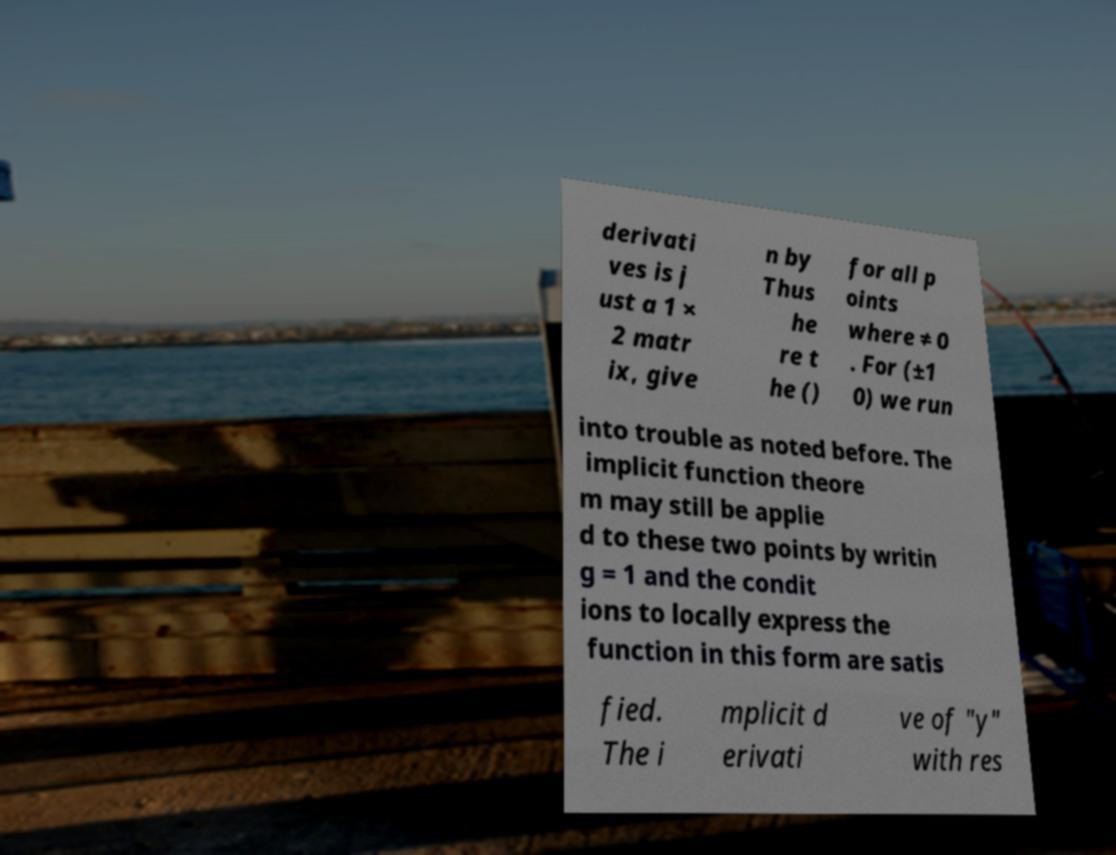What messages or text are displayed in this image? I need them in a readable, typed format. derivati ves is j ust a 1 × 2 matr ix, give n by Thus he re t he () for all p oints where ≠ 0 . For (±1 0) we run into trouble as noted before. The implicit function theore m may still be applie d to these two points by writin g = 1 and the condit ions to locally express the function in this form are satis fied. The i mplicit d erivati ve of "y" with res 